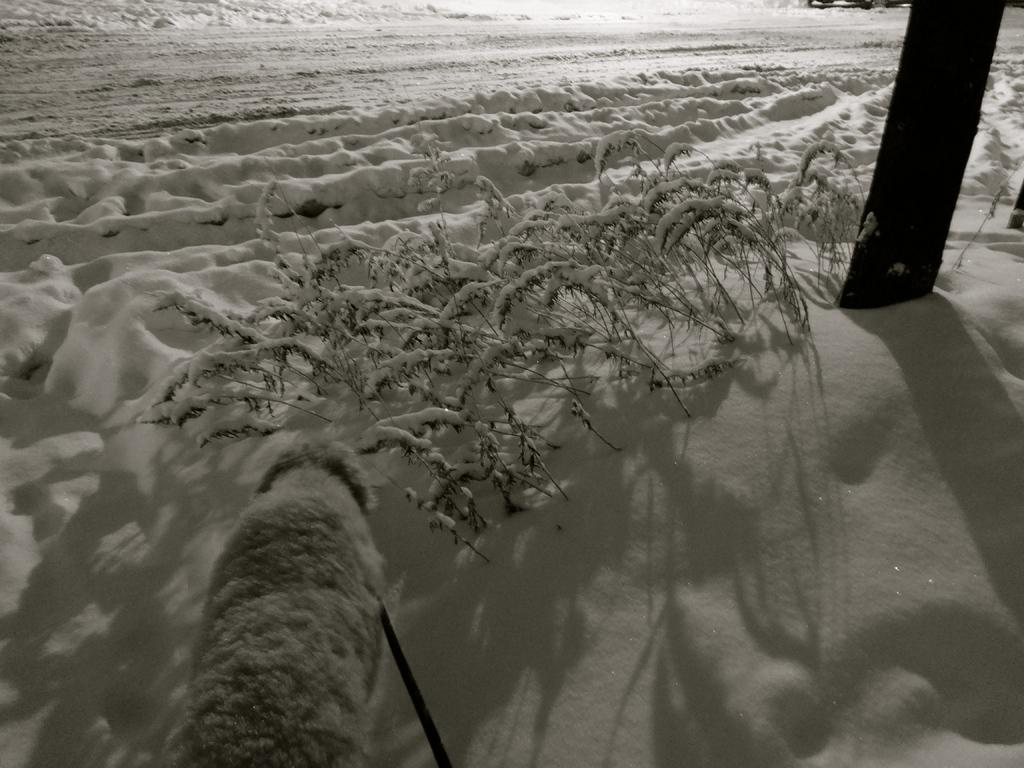What is present in the foreground of the image? There is snow, plants, and a pole in the foreground of the image. Can you describe the plants in the foreground? The plants in the foreground are partially covered by snow. What is visible in the background of the image? There is snow visible in the background of the image. Is there a scarecrow standing at the edge of the image? There is no scarecrow present in the image, and the edge of the image is not mentioned in the provided facts. 